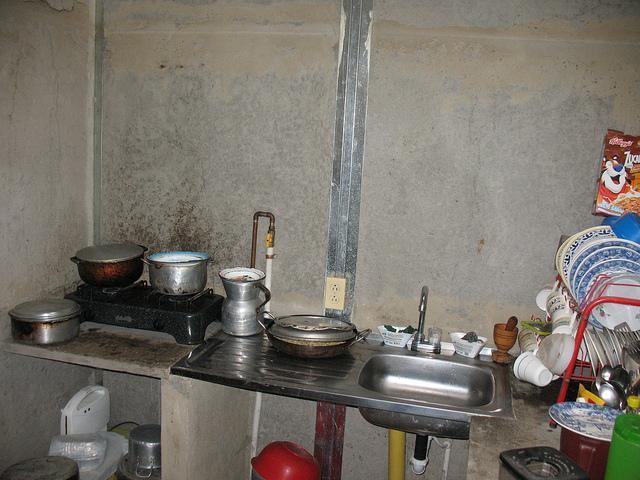How many bowls are there?
Give a very brief answer. 3. How many bottles are visible?
Give a very brief answer. 1. 